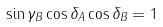<formula> <loc_0><loc_0><loc_500><loc_500>\sin \gamma _ { B } \cos \delta _ { A } \cos \delta _ { B } = 1</formula> 